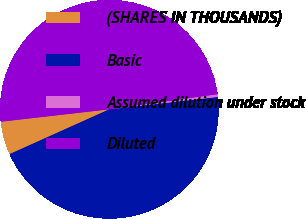<chart> <loc_0><loc_0><loc_500><loc_500><pie_chart><fcel>(SHARES IN THOUSANDS)<fcel>Basic<fcel>Assumed dilution under stock<fcel>Diluted<nl><fcel>4.91%<fcel>45.09%<fcel>0.4%<fcel>49.6%<nl></chart> 